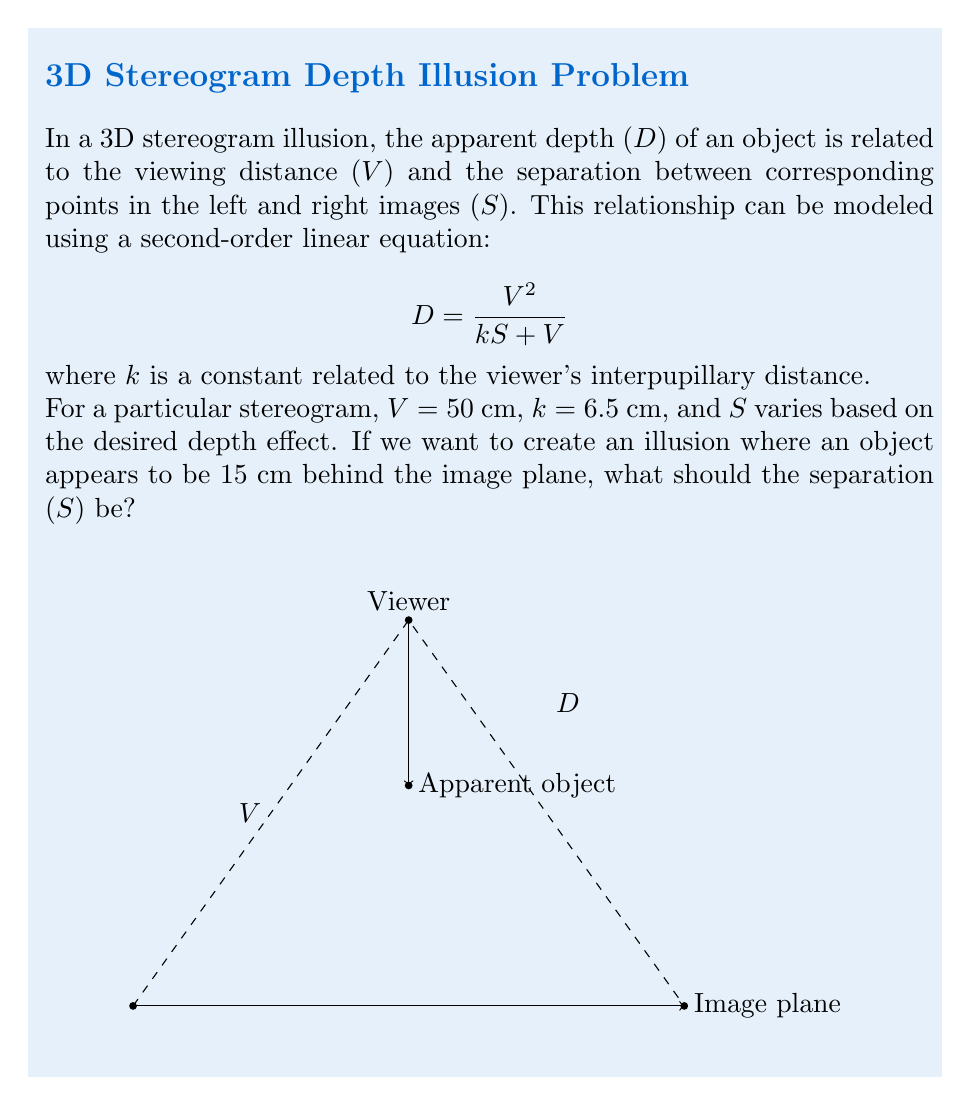Can you solve this math problem? Let's approach this step-by-step:

1) We're given the second-order linear equation:

   $$D = \frac{V^2}{kS + V}$$

2) We know the following values:
   - D = 15 cm (desired apparent depth)
   - V = 50 cm (viewing distance)
   - k = 6.5 cm (constant related to interpupillary distance)

3) We need to solve for S. Let's start by substituting the known values into the equation:

   $$15 = \frac{50^2}{6.5S + 50}$$

4) Simplify the numerator:

   $$15 = \frac{2500}{6.5S + 50}$$

5) Multiply both sides by (6.5S + 50):

   $$15(6.5S + 50) = 2500$$

6) Distribute on the left side:

   $$97.5S + 750 = 2500$$

7) Subtract 750 from both sides:

   $$97.5S = 1750$$

8) Divide both sides by 97.5:

   $$S = \frac{1750}{97.5} \approx 17.95$$

Therefore, the separation (S) should be approximately 17.95 cm.
Answer: $S \approx 17.95$ cm 